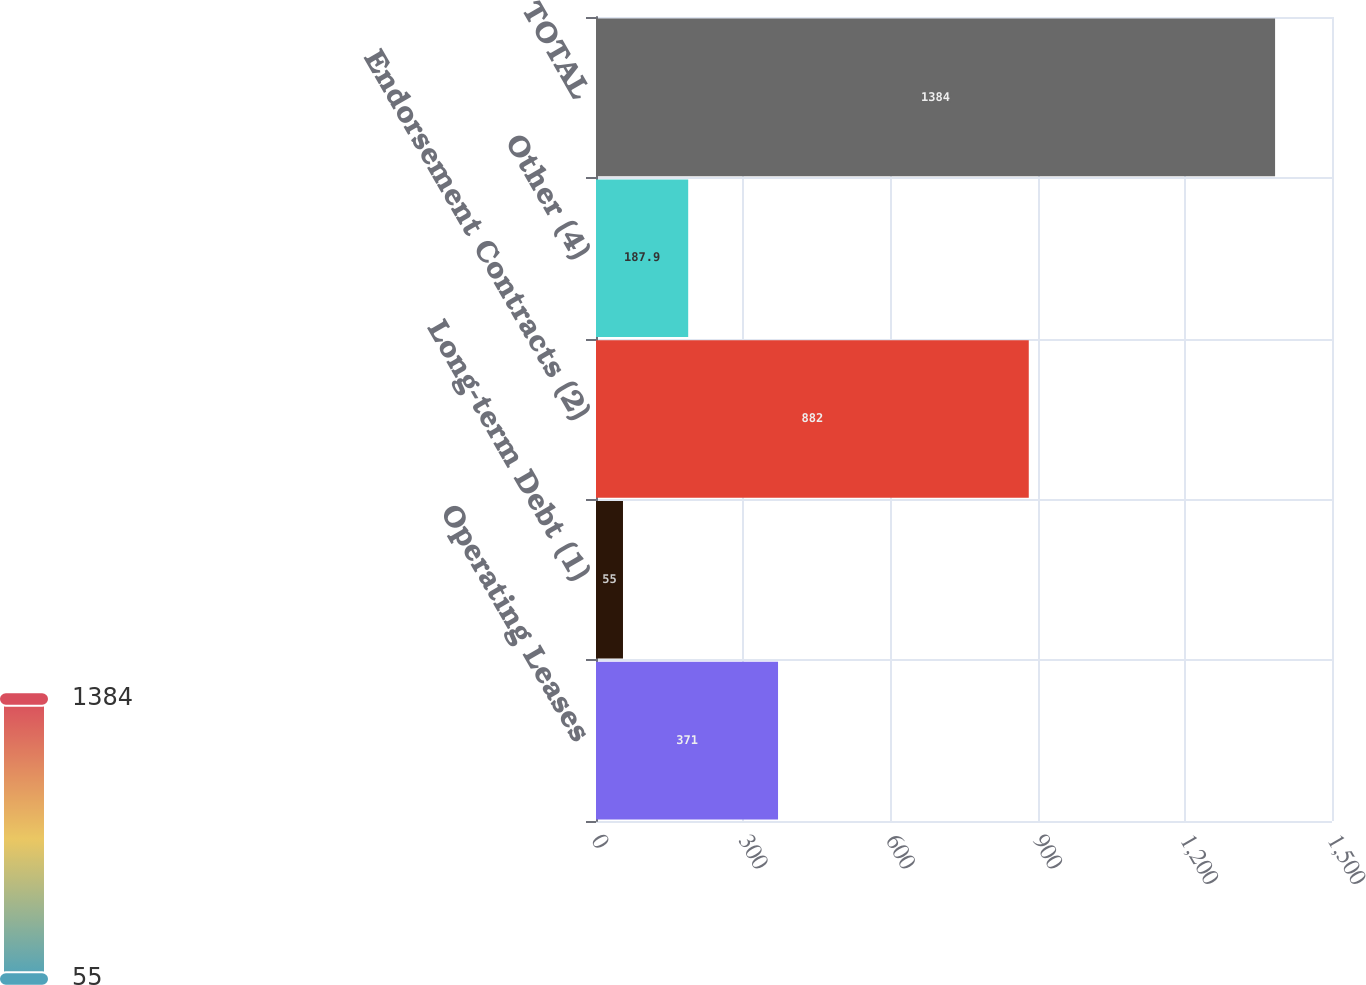<chart> <loc_0><loc_0><loc_500><loc_500><bar_chart><fcel>Operating Leases<fcel>Long-term Debt (1)<fcel>Endorsement Contracts (2)<fcel>Other (4)<fcel>TOTAL<nl><fcel>371<fcel>55<fcel>882<fcel>187.9<fcel>1384<nl></chart> 